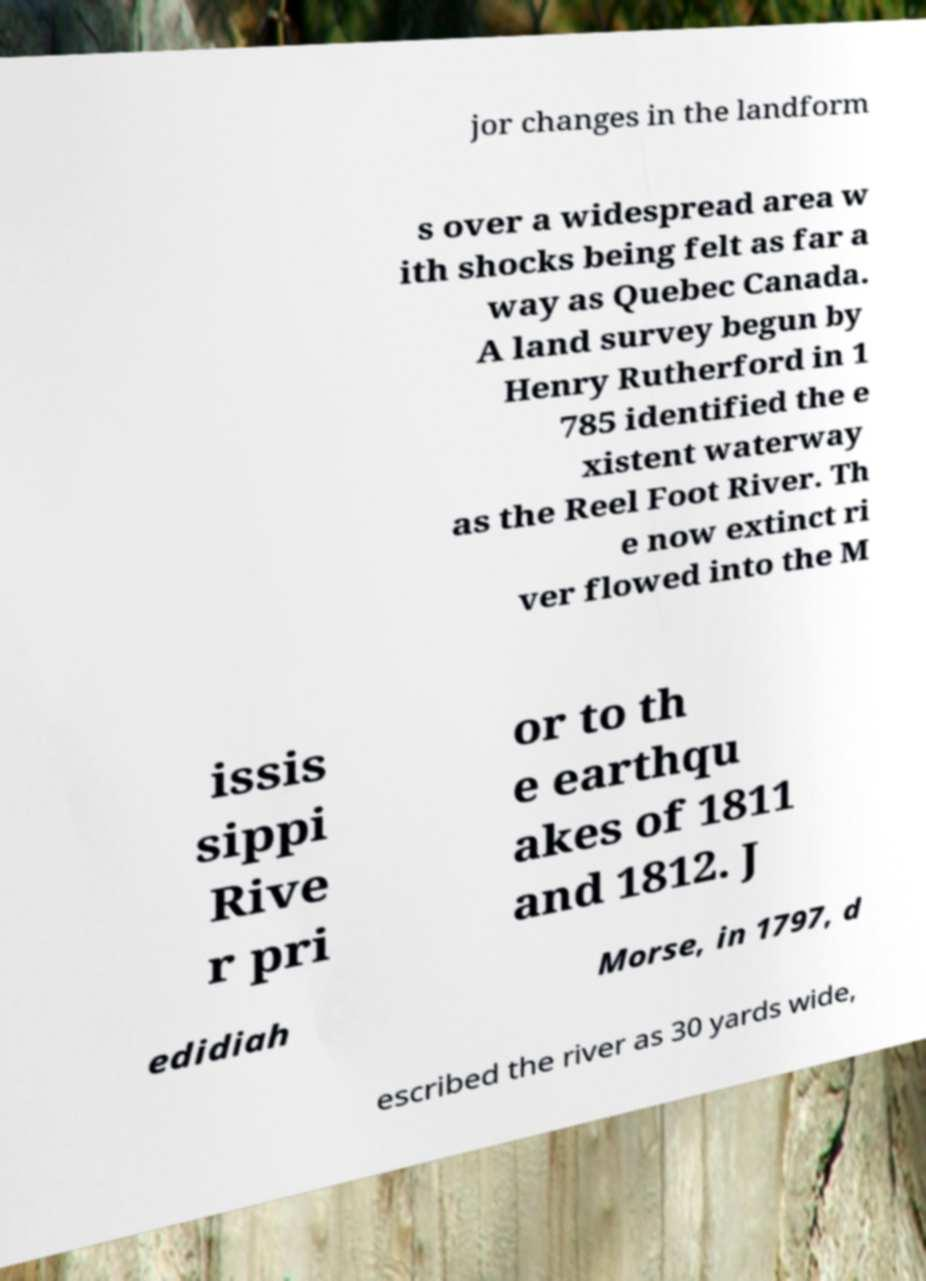Please identify and transcribe the text found in this image. jor changes in the landform s over a widespread area w ith shocks being felt as far a way as Quebec Canada. A land survey begun by Henry Rutherford in 1 785 identified the e xistent waterway as the Reel Foot River. Th e now extinct ri ver flowed into the M issis sippi Rive r pri or to th e earthqu akes of 1811 and 1812. J edidiah Morse, in 1797, d escribed the river as 30 yards wide, 